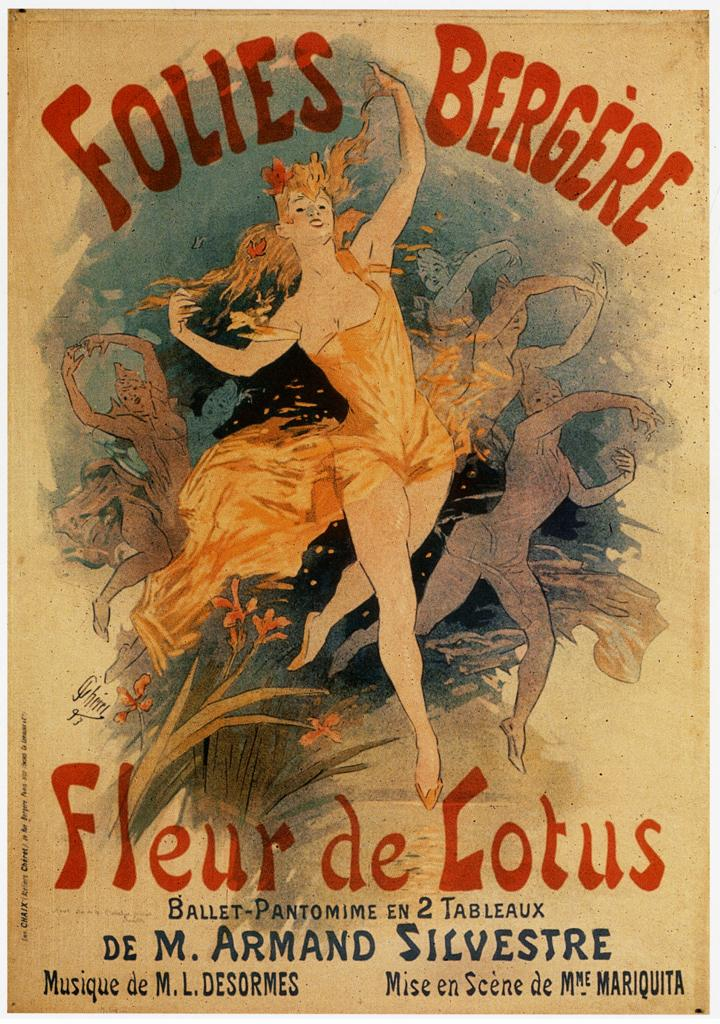<image>
Relay a brief, clear account of the picture shown. A poster for Fleur De Lotus has a woman dancing ballet on the front 